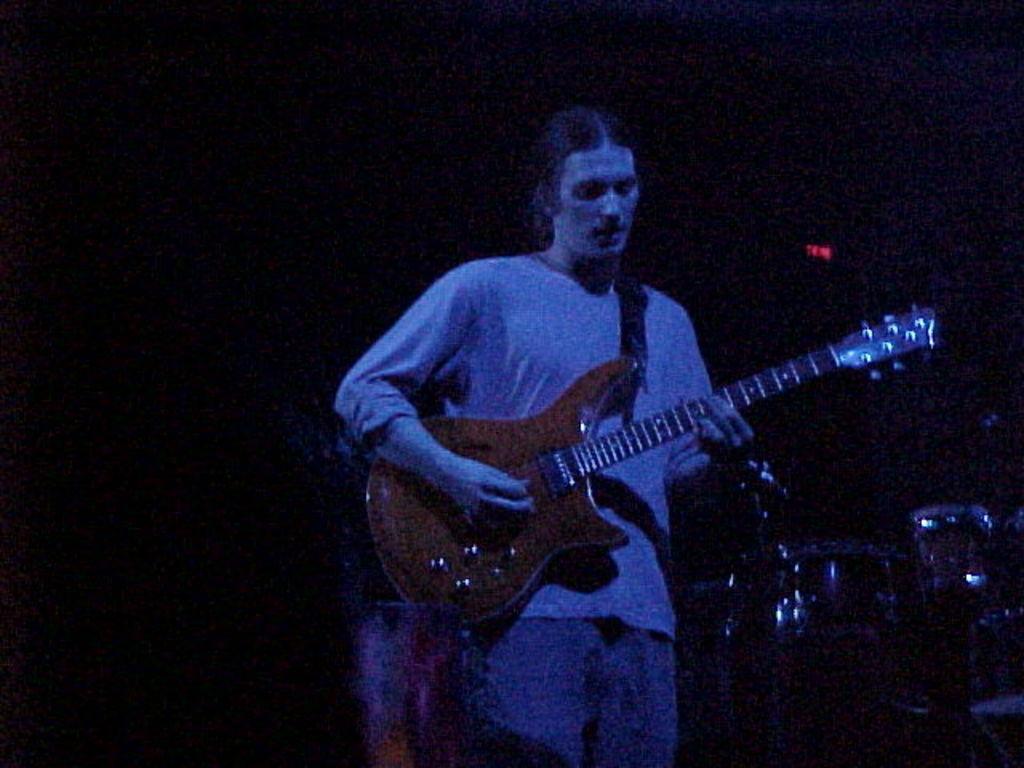In one or two sentences, can you explain what this image depicts? In this image we can see a person playing a guitar. In the back there are drums. And it is looking dark in the background. 